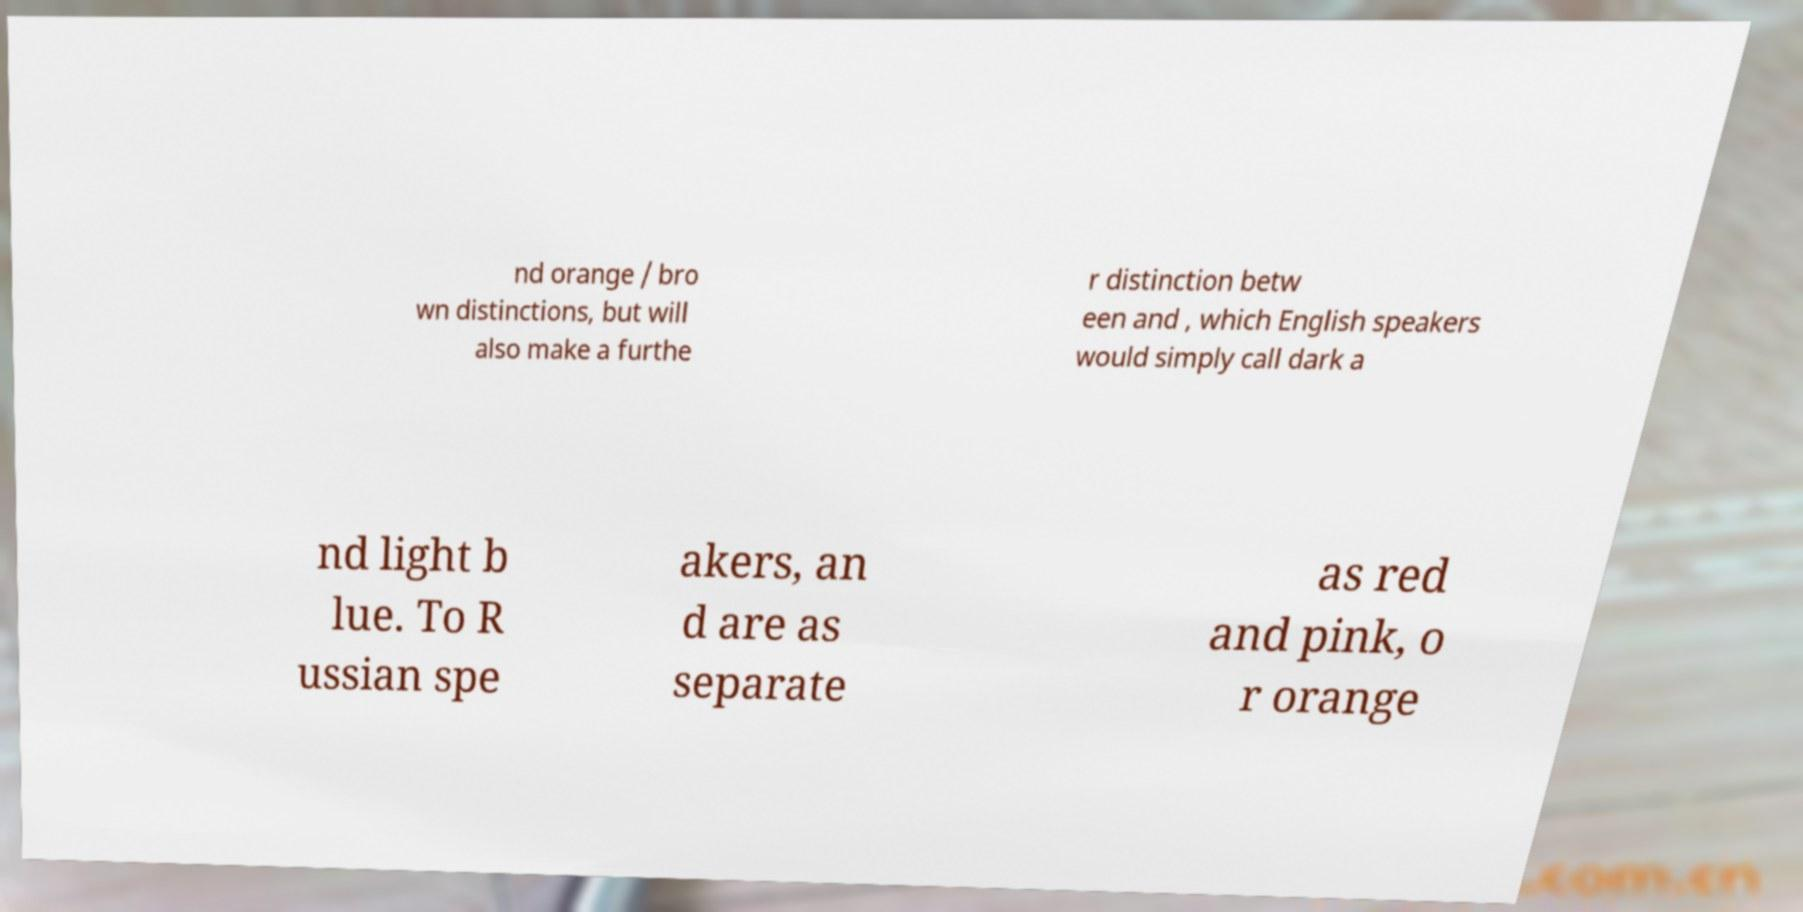I need the written content from this picture converted into text. Can you do that? nd orange / bro wn distinctions, but will also make a furthe r distinction betw een and , which English speakers would simply call dark a nd light b lue. To R ussian spe akers, an d are as separate as red and pink, o r orange 